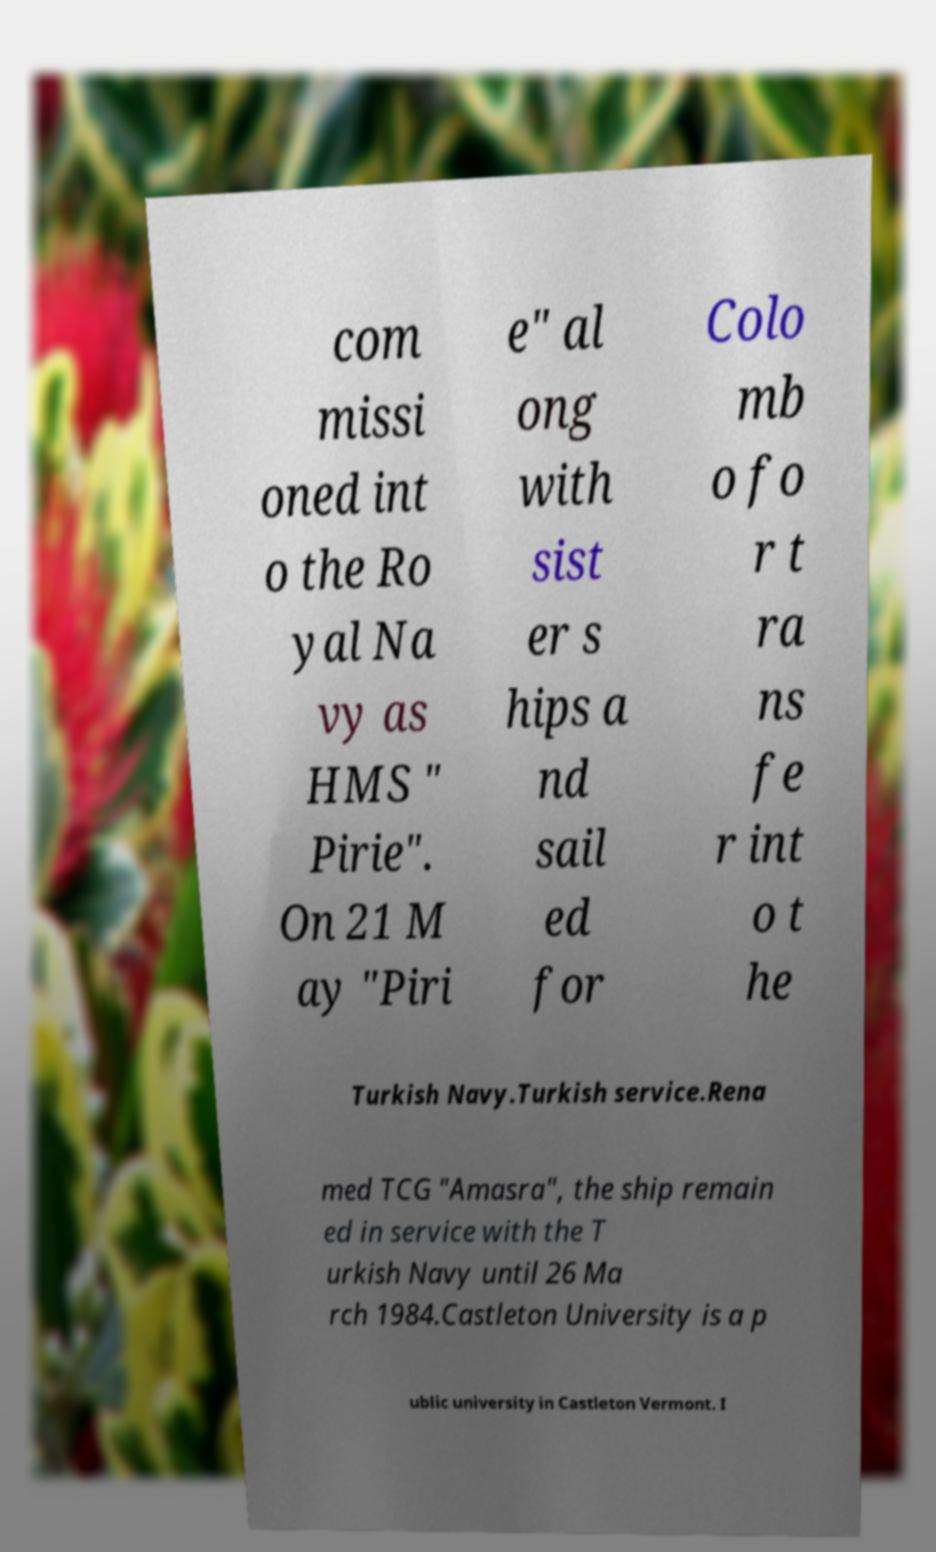There's text embedded in this image that I need extracted. Can you transcribe it verbatim? com missi oned int o the Ro yal Na vy as HMS " Pirie". On 21 M ay "Piri e" al ong with sist er s hips a nd sail ed for Colo mb o fo r t ra ns fe r int o t he Turkish Navy.Turkish service.Rena med TCG "Amasra", the ship remain ed in service with the T urkish Navy until 26 Ma rch 1984.Castleton University is a p ublic university in Castleton Vermont. I 